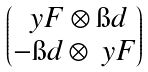Convert formula to latex. <formula><loc_0><loc_0><loc_500><loc_500>\begin{pmatrix} \ y F \otimes \i d \\ - \i d \otimes \ y F \end{pmatrix}</formula> 